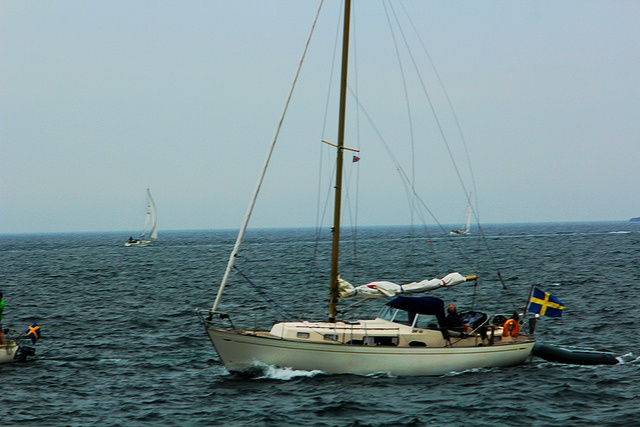Describe the objects in this image and their specific colors. I can see boat in lightgray, lightblue, teal, and darkgray tones, boat in lightgray, darkgray, gray, teal, and blue tones, boat in lightgray, black, gray, darkgreen, and maroon tones, people in lightgray, black, maroon, and gray tones, and people in lightgray, black, purple, teal, and gray tones in this image. 